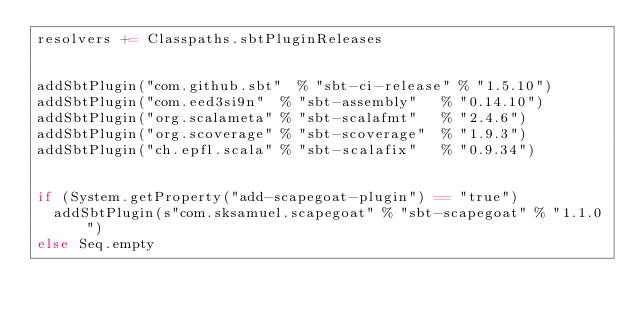Convert code to text. <code><loc_0><loc_0><loc_500><loc_500><_Scala_>resolvers += Classpaths.sbtPluginReleases


addSbtPlugin("com.github.sbt"  % "sbt-ci-release" % "1.5.10")
addSbtPlugin("com.eed3si9n"  % "sbt-assembly"   % "0.14.10")
addSbtPlugin("org.scalameta" % "sbt-scalafmt"   % "2.4.6")
addSbtPlugin("org.scoverage" % "sbt-scoverage"  % "1.9.3")
addSbtPlugin("ch.epfl.scala" % "sbt-scalafix"   % "0.9.34")


if (System.getProperty("add-scapegoat-plugin") == "true")
  addSbtPlugin(s"com.sksamuel.scapegoat" % "sbt-scapegoat" % "1.1.0")
else Seq.empty
</code> 